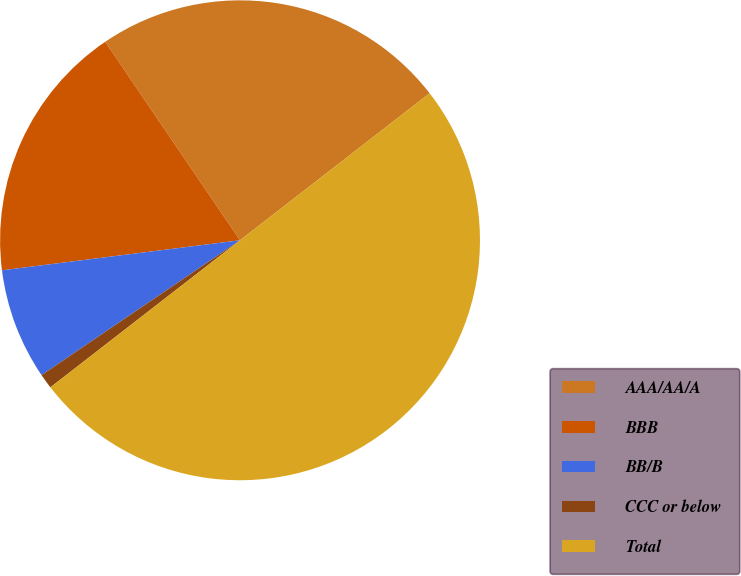<chart> <loc_0><loc_0><loc_500><loc_500><pie_chart><fcel>AAA/AA/A<fcel>BBB<fcel>BB/B<fcel>CCC or below<fcel>Total<nl><fcel>24.0%<fcel>17.5%<fcel>7.5%<fcel>1.0%<fcel>50.0%<nl></chart> 